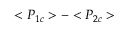<formula> <loc_0><loc_0><loc_500><loc_500>< P _ { 1 c } > - < P _ { 2 c } ></formula> 